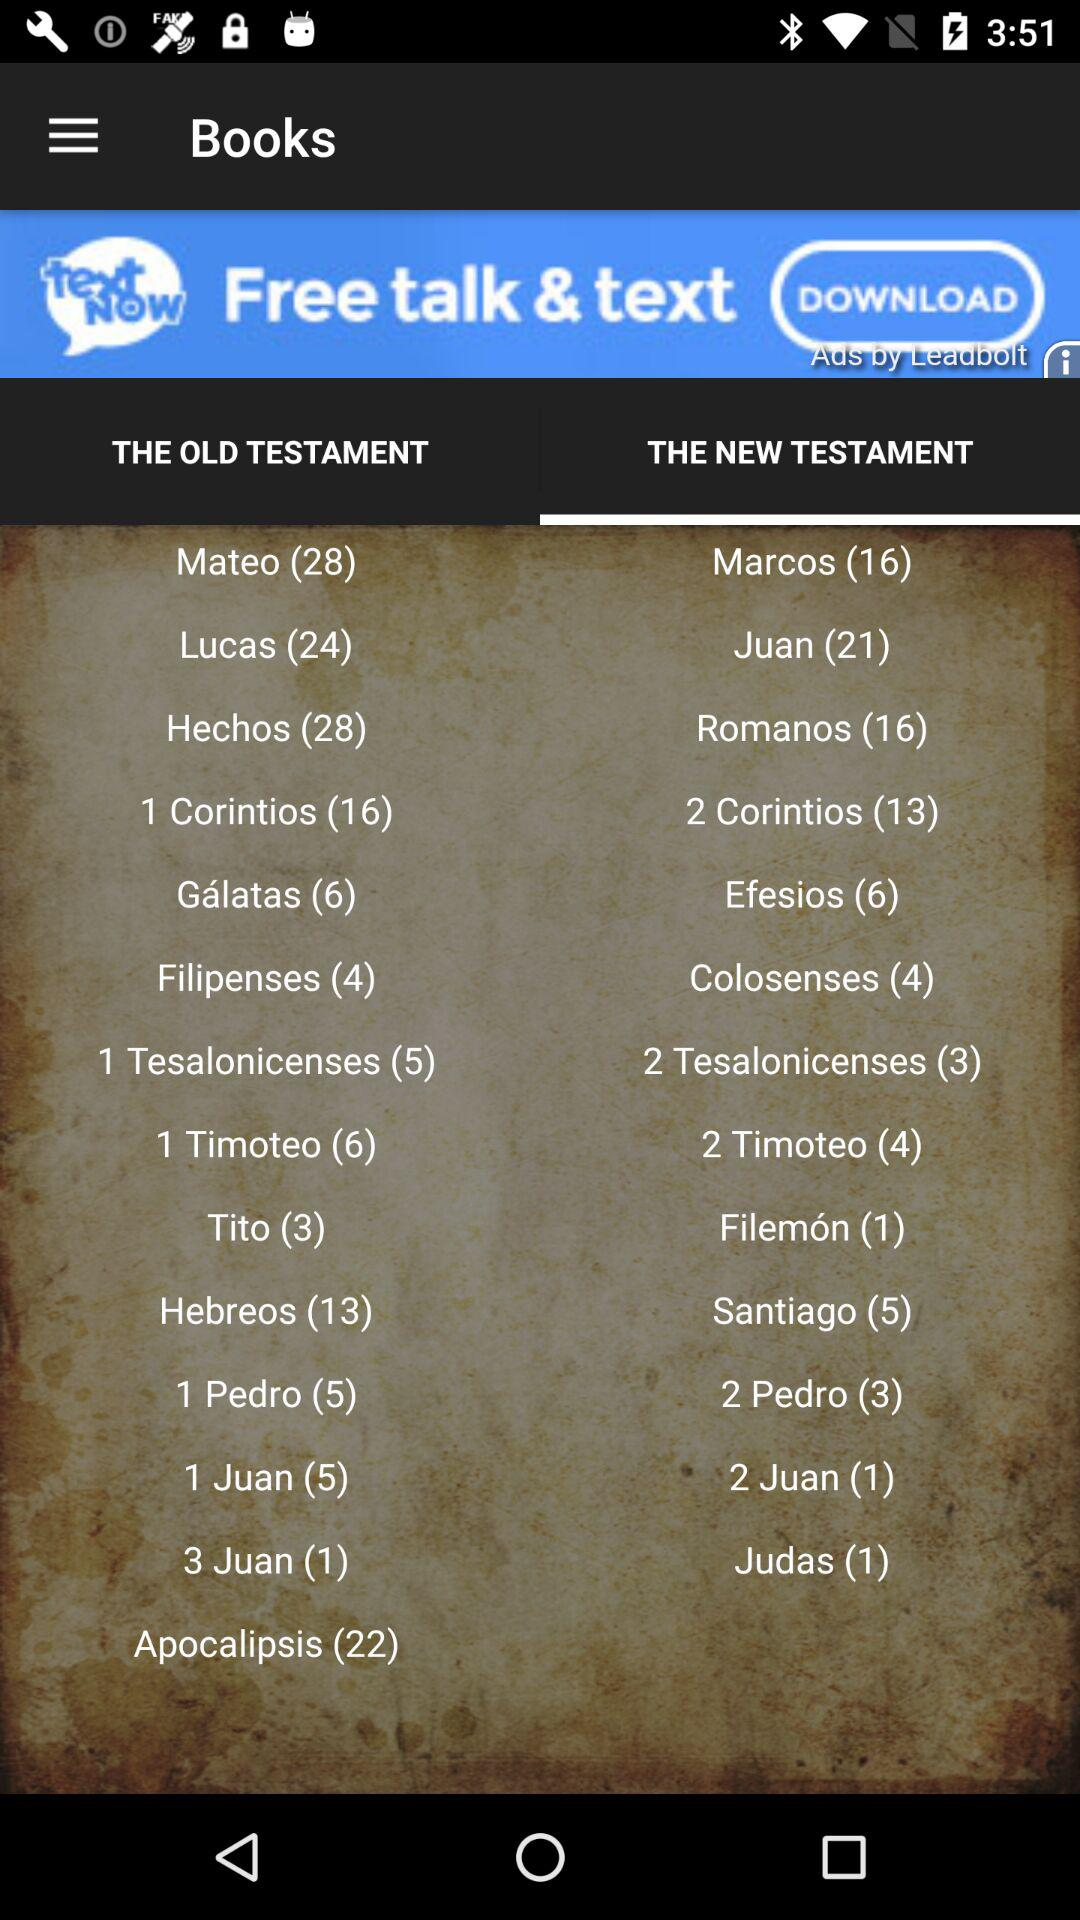Which testament contains the greatest number of books? The testament which contains the greatest number of books is "THE OLD TESTAMENT". 